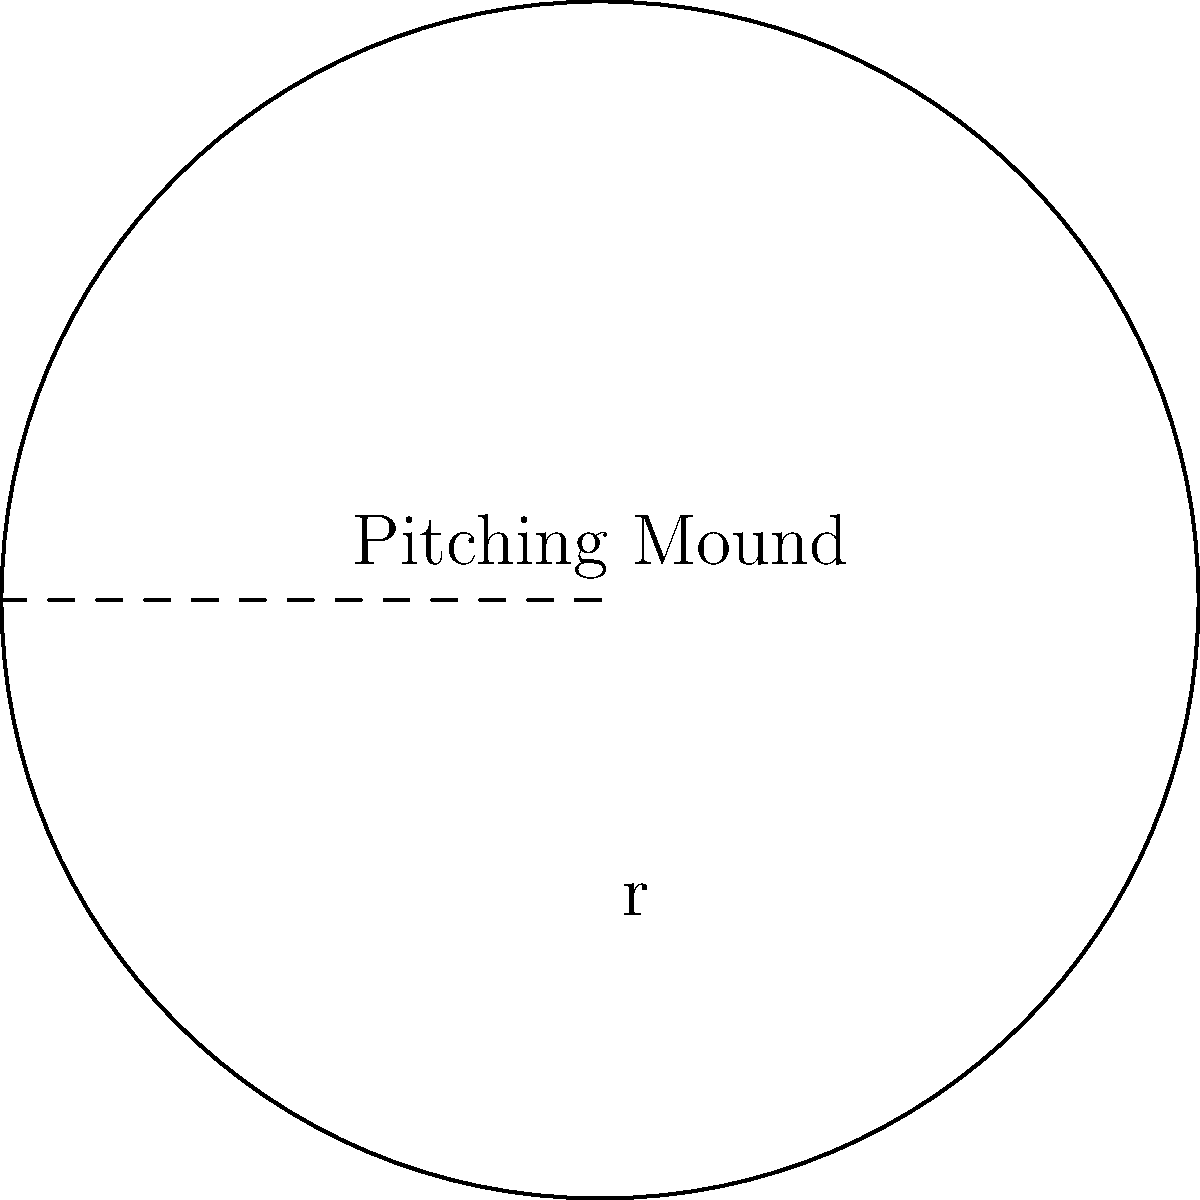As a baseball pitcher, you're curious about the area of the circular pitching mound. If the radius of the mound is 9 feet, what is its total area in square feet? Round your answer to the nearest square foot. To solve this problem, we'll use the formula for the area of a circle:

$$A = \pi r^2$$

Where:
$A$ = area of the circle
$\pi$ = pi (approximately 3.14159)
$r$ = radius of the circle

Given:
- Radius of the pitching mound = 9 feet

Step 1: Substitute the given radius into the formula.
$$A = \pi (9)^2$$

Step 2: Calculate the square of the radius.
$$A = \pi (81)$$

Step 3: Multiply by π.
$$A = 3.14159 \times 81 = 254.47 \text{ square feet}$$

Step 4: Round to the nearest square foot.
$$A \approx 254 \text{ square feet}$$

This calculation gives us the total area of the circular pitching mound, which is important for understanding the space you have to work with during your pitching motion and for maintaining the mound's surface area for optimal performance.
Answer: 254 square feet 